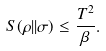Convert formula to latex. <formula><loc_0><loc_0><loc_500><loc_500>S ( \rho | | \sigma ) \leq \frac { T ^ { 2 } } { \beta } .</formula> 